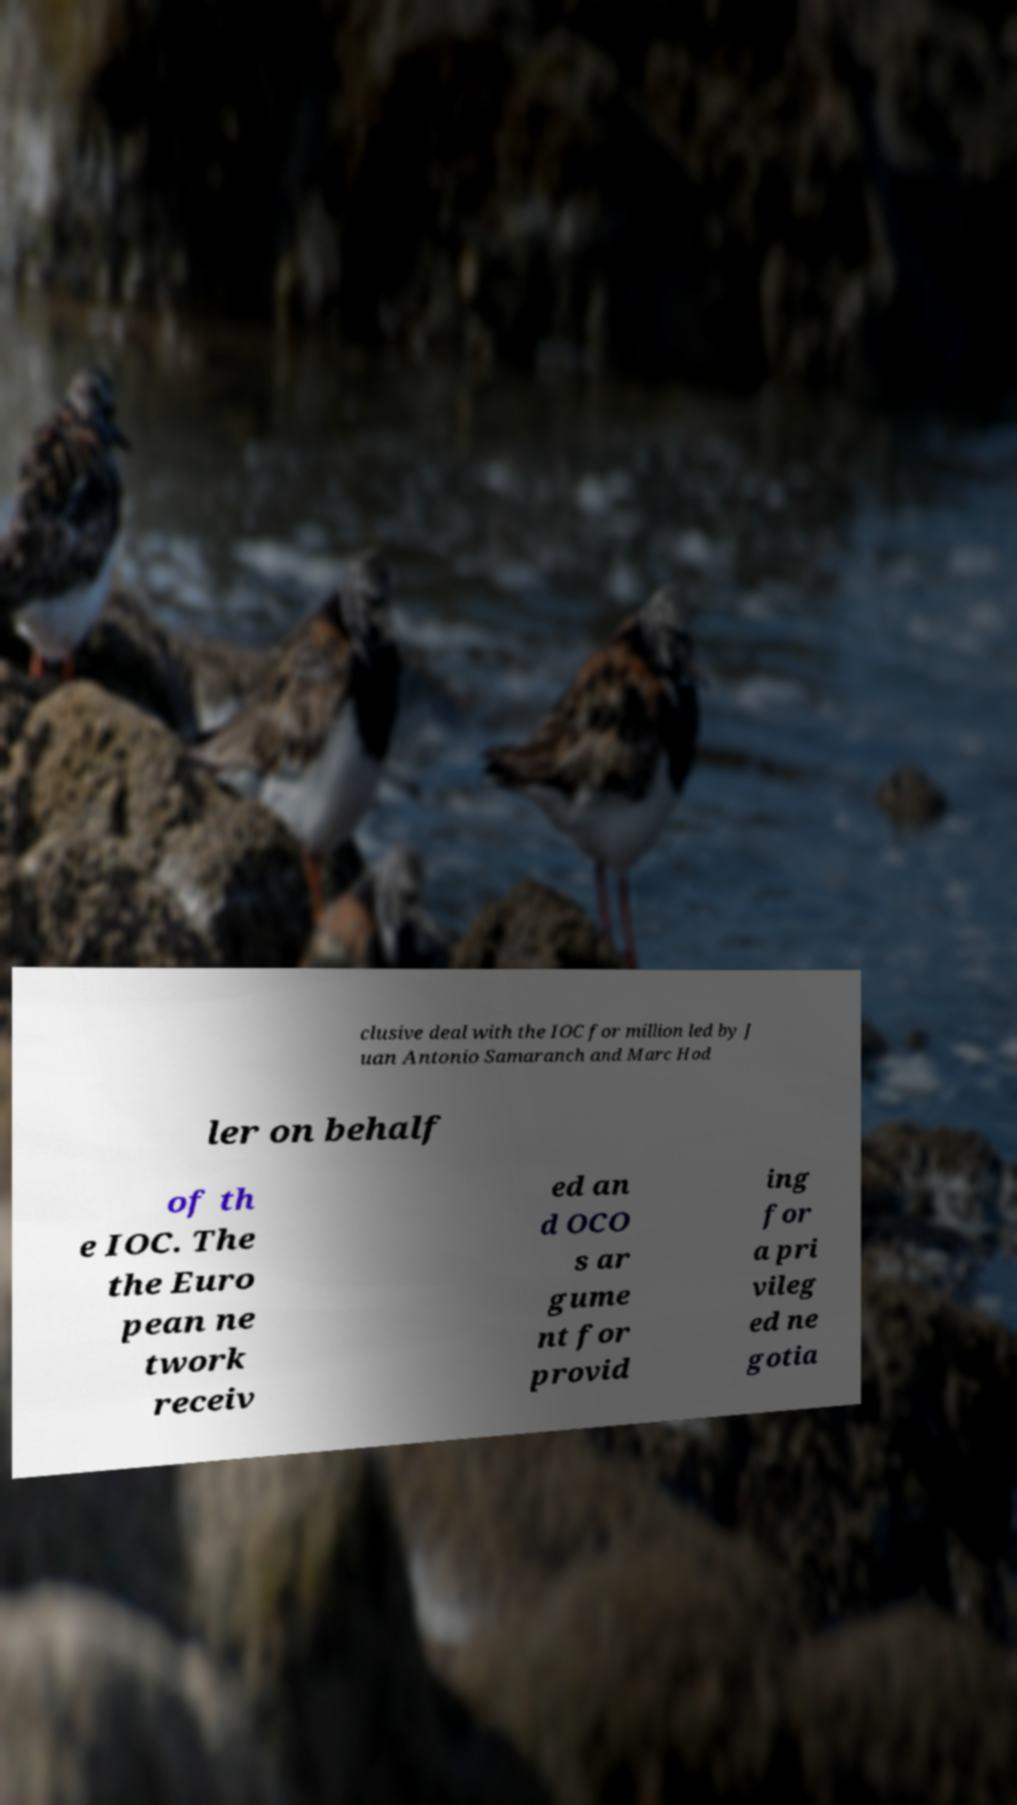There's text embedded in this image that I need extracted. Can you transcribe it verbatim? clusive deal with the IOC for million led by J uan Antonio Samaranch and Marc Hod ler on behalf of th e IOC. The the Euro pean ne twork receiv ed an d OCO s ar gume nt for provid ing for a pri vileg ed ne gotia 